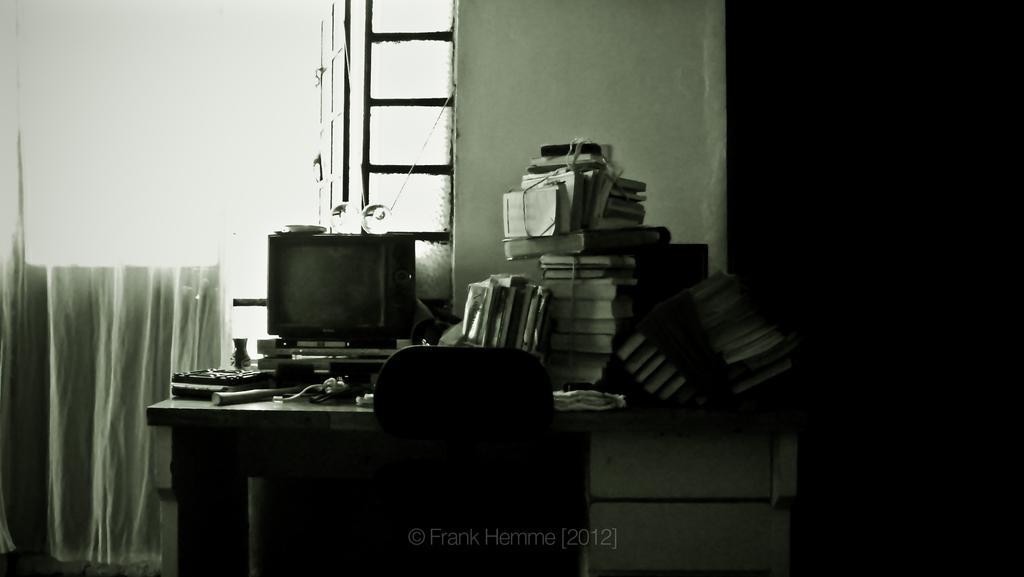Could you give a brief overview of what you see in this image? In this picture I can see electronic device on the table. I can see a number of books on the table. I can see sitting chair. I can see windows. I can see the curtain on the left side. 